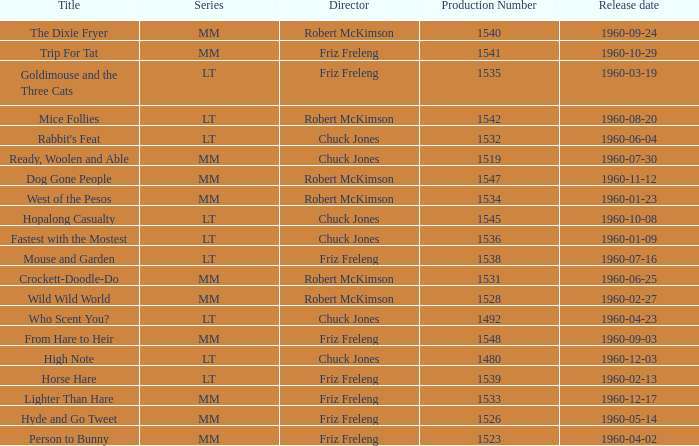What is the Series number of the episode with a production number of 1547? MM. 